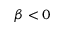Convert formula to latex. <formula><loc_0><loc_0><loc_500><loc_500>\beta < 0</formula> 